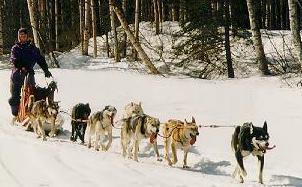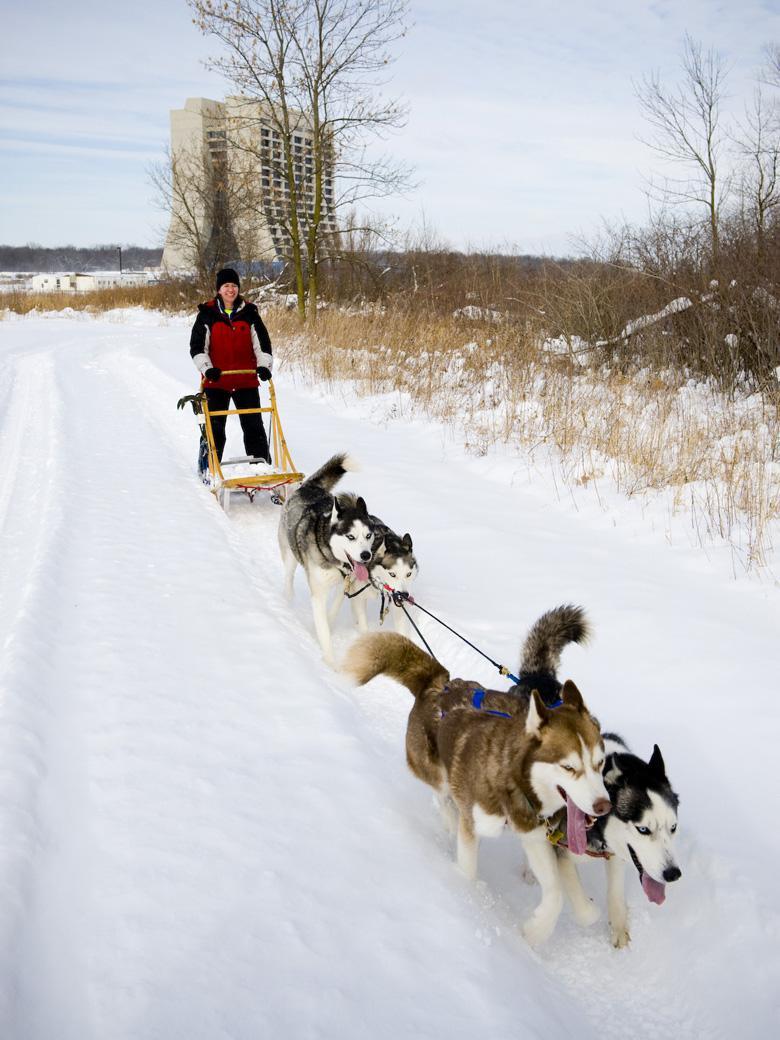The first image is the image on the left, the second image is the image on the right. Evaluate the accuracy of this statement regarding the images: "Right image shows a sled team heading rightward and downward, with no vegetation along the trail.". Is it true? Answer yes or no. No. 